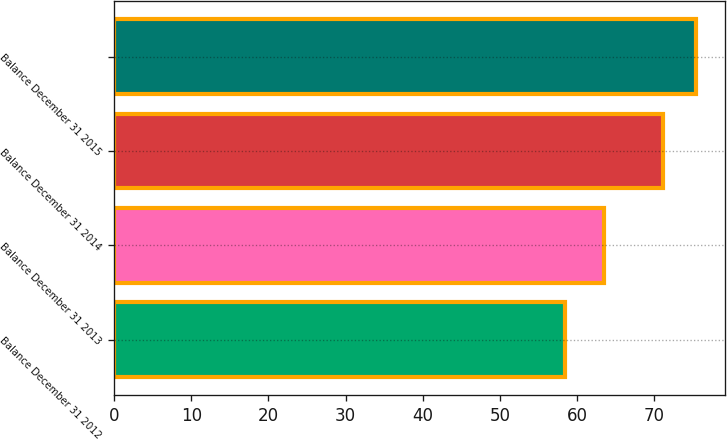<chart> <loc_0><loc_0><loc_500><loc_500><bar_chart><fcel>Balance December 31 2012<fcel>Balance December 31 2013<fcel>Balance December 31 2014<fcel>Balance December 31 2015<nl><fcel>58.44<fcel>63.53<fcel>71.14<fcel>75.41<nl></chart> 